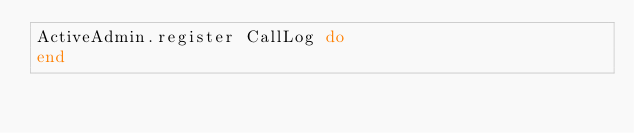<code> <loc_0><loc_0><loc_500><loc_500><_Ruby_>ActiveAdmin.register CallLog do  
end
</code> 